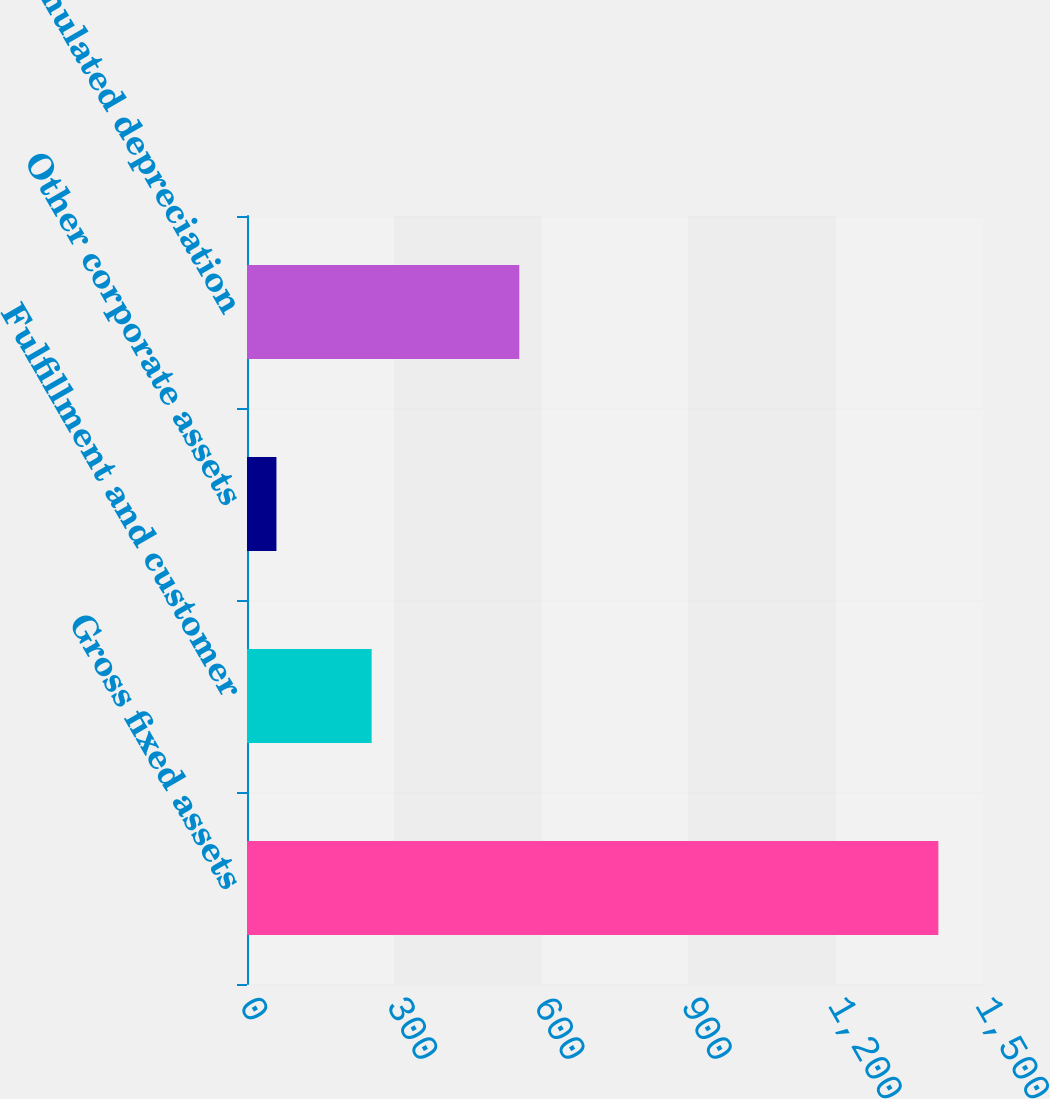Convert chart. <chart><loc_0><loc_0><loc_500><loc_500><bar_chart><fcel>Gross fixed assets<fcel>Fulfillment and customer<fcel>Other corporate assets<fcel>Total accumulated depreciation<nl><fcel>1409<fcel>254<fcel>60<fcel>555<nl></chart> 